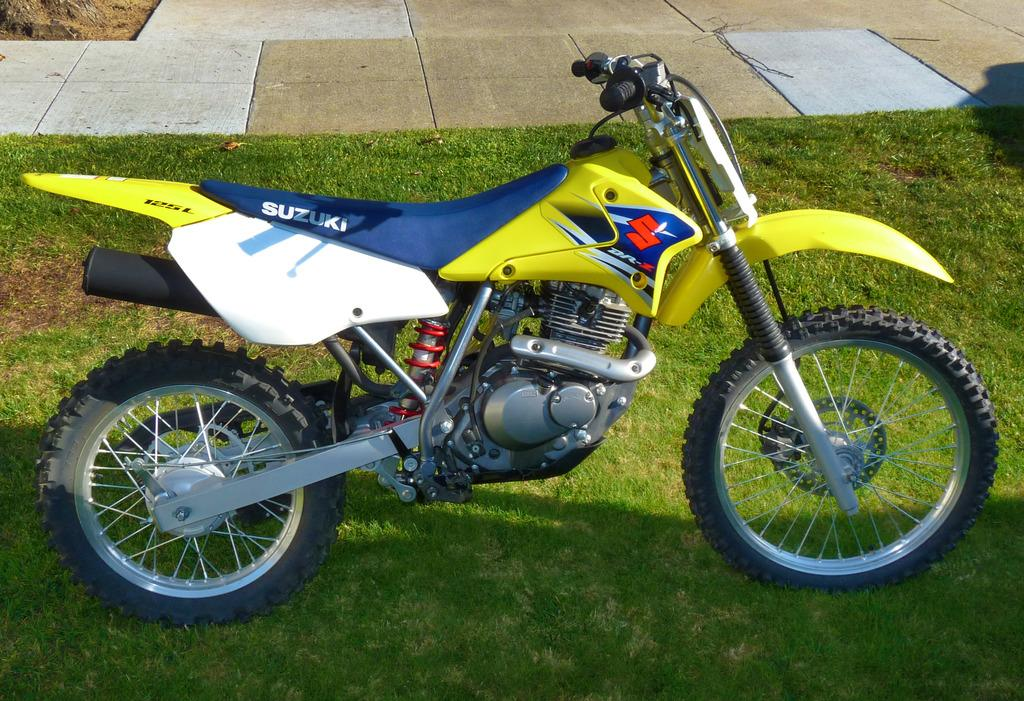What is the main object in the image? There is a bike in the image. Where is the bike located? The bike is on a grassland. What type of surface can be seen in the background of the image? There are tiles visible in the background of the image. What is the name of the rose in the image? There is no rose present in the image. Can you hear the bike in the image? The image is a still picture, so it does not have any sound associated with it. 